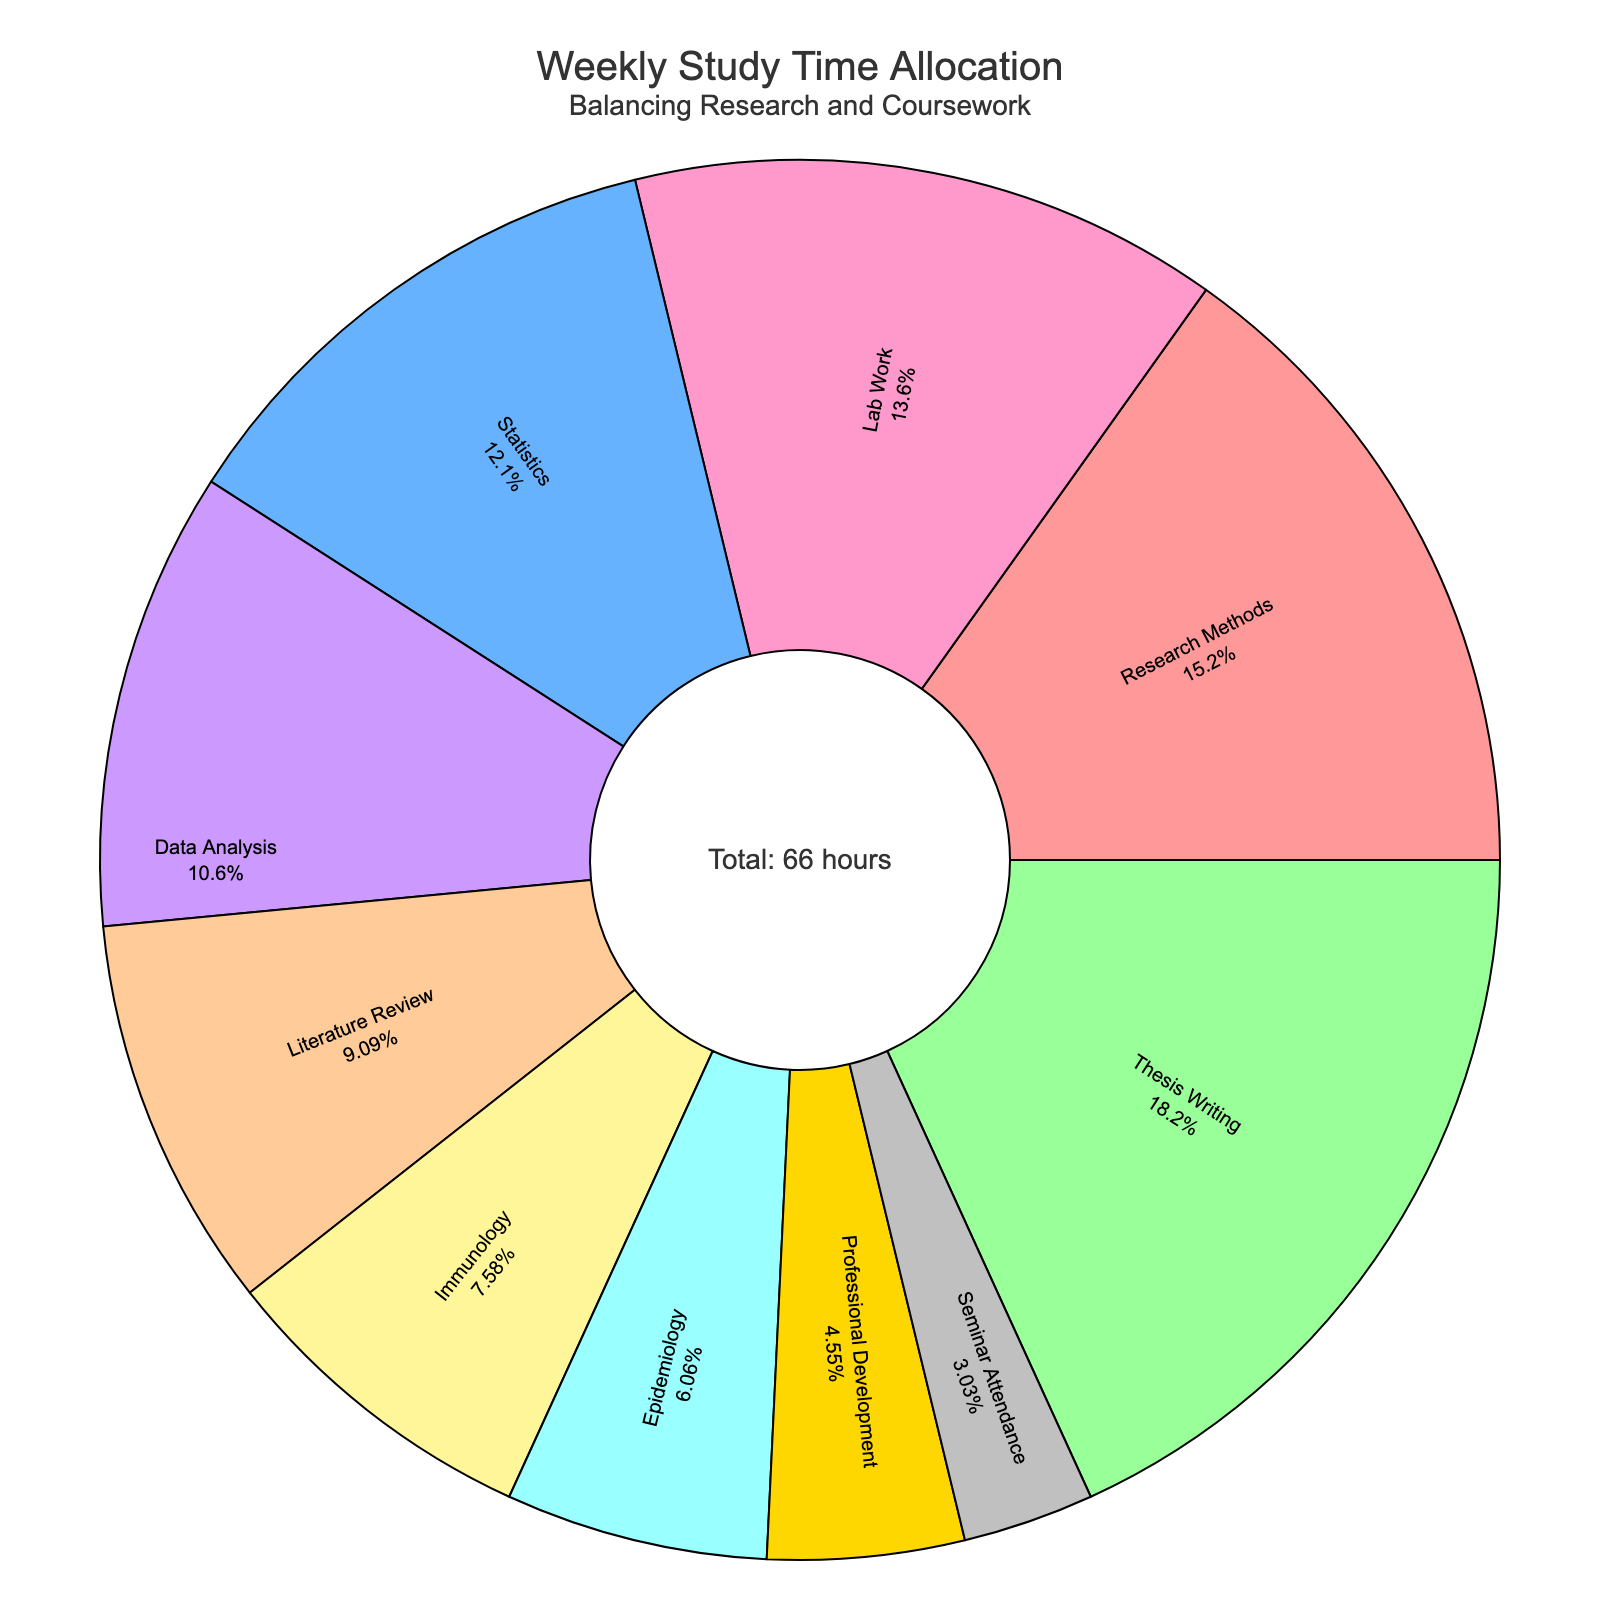What's the total amount of study hours dedicated to Research Methods and Lab Work combined? To find the total study hours for Research Methods and Lab Work, add their hours per week. Research Methods has 10 hours and Lab Work has 9 hours, so the combined total is 10 + 9.
Answer: 19 Which subject has the highest study time allocation? Look at the pie chart and identify the segment with the largest size. Thesis Writing has the most significant portion of the pie chart.
Answer: Thesis Writing What percentage of the total study time is spent on Thesis Writing? Locate the Thesis Writing section in the pie chart which shows both the label and the percentage. The pie chart indicates that Thesis Writing is 22% of the total study time.
Answer: 22% Compare the study hours between Data Analysis and Statistics. Which one has more? Compare the sizes of the Data Analysis and Statistics segments in the pie chart. Data Analysis has 7 hours, while Statistics has 8 hours.
Answer: Statistics How many total hours per week are allocated to subjects that have less than 5 hours? Identify subjects with study time less than 5 hours: Epidemiology (4) and Seminar Attendance (2). Add their hours: 4 + 2 = 6.
Answer: 6 By how many hours does Thesis Writing exceed Immunology? Determine the hours allocated to each subject: Thesis Writing (12) and Immunology (5). Subtract the two values: 12 - 5 = 7.
Answer: 7 If you combine the time dedicated to Data Analysis, Statistics, and Immunology, what's the total? Add the hours of Data Analysis (7), Statistics (8), and Immunology (5): 7 + 8 + 5 = 20.
Answer: 20 Which subject is represented by the light blue color in the pie chart? Identify the segment colored light blue. According to the color scheme, light blue represents Statistics.
Answer: Statistics If Professional Development hours were doubled, what would be the new total study hours in the week? Current Professional Development hours are 3. Doubling this makes 6. The original total study hours are 66. Add the extra 3 hours: 66 + 3 = 69.
Answer: 69 Is the time spent on Thesis Writing greater than or equal to the combined time for Literature Review and Immunology? Hours for Thesis Writing are 12. Combined hours for Literature Review (6) and Immunology (5) are 6 + 5 = 11. Thesis Writing's 12 hours are more than 11 hours for the combined subjects.
Answer: Yes 